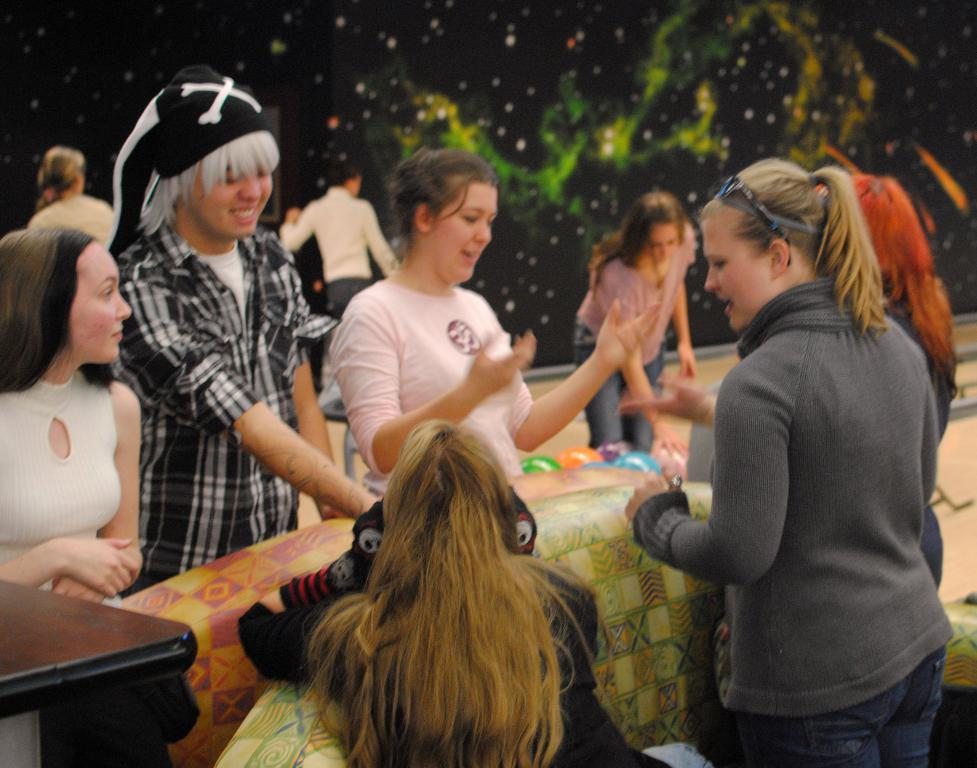What types of people are present in the image? There are women standing and sitting in the image. What decorative items can be seen in the image? There are balloons in the image. Where is the table located in the image? The table is in the bottom left corner of the image. What type of industry is depicted in the image? There is no industry present in the image; it features women and balloons. How many spiders can be seen crawling on the table in the image? There are no spiders present in the image; it only features women, balloons, and a table. 